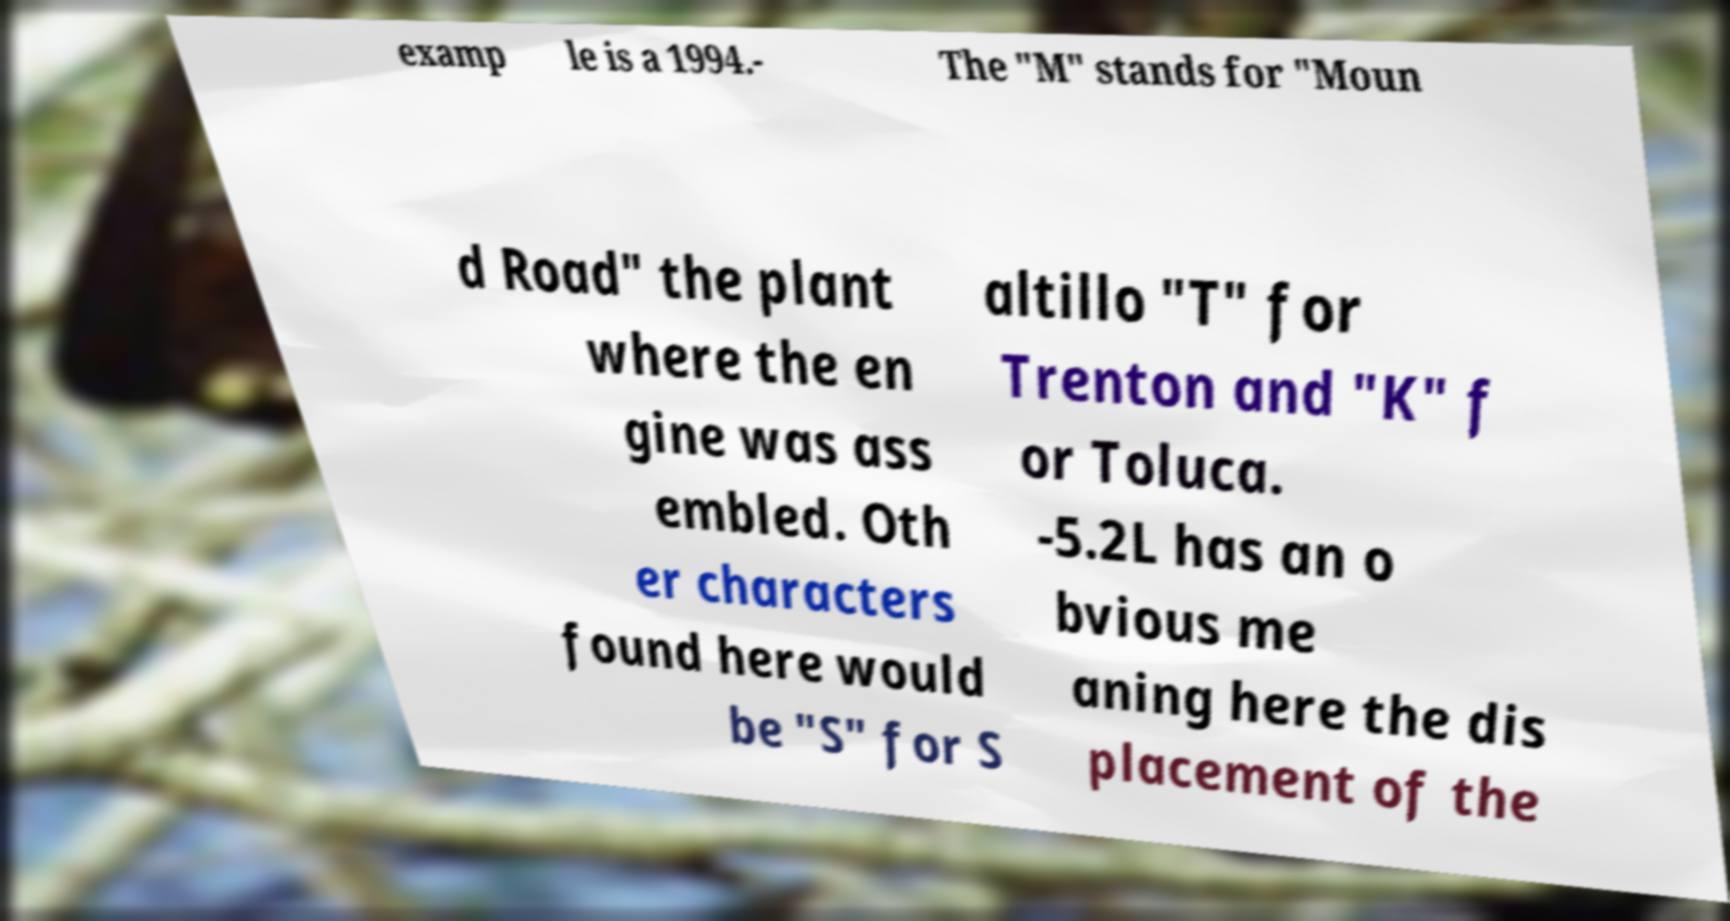For documentation purposes, I need the text within this image transcribed. Could you provide that? examp le is a 1994.- The "M" stands for "Moun d Road" the plant where the en gine was ass embled. Oth er characters found here would be "S" for S altillo "T" for Trenton and "K" f or Toluca. -5.2L has an o bvious me aning here the dis placement of the 